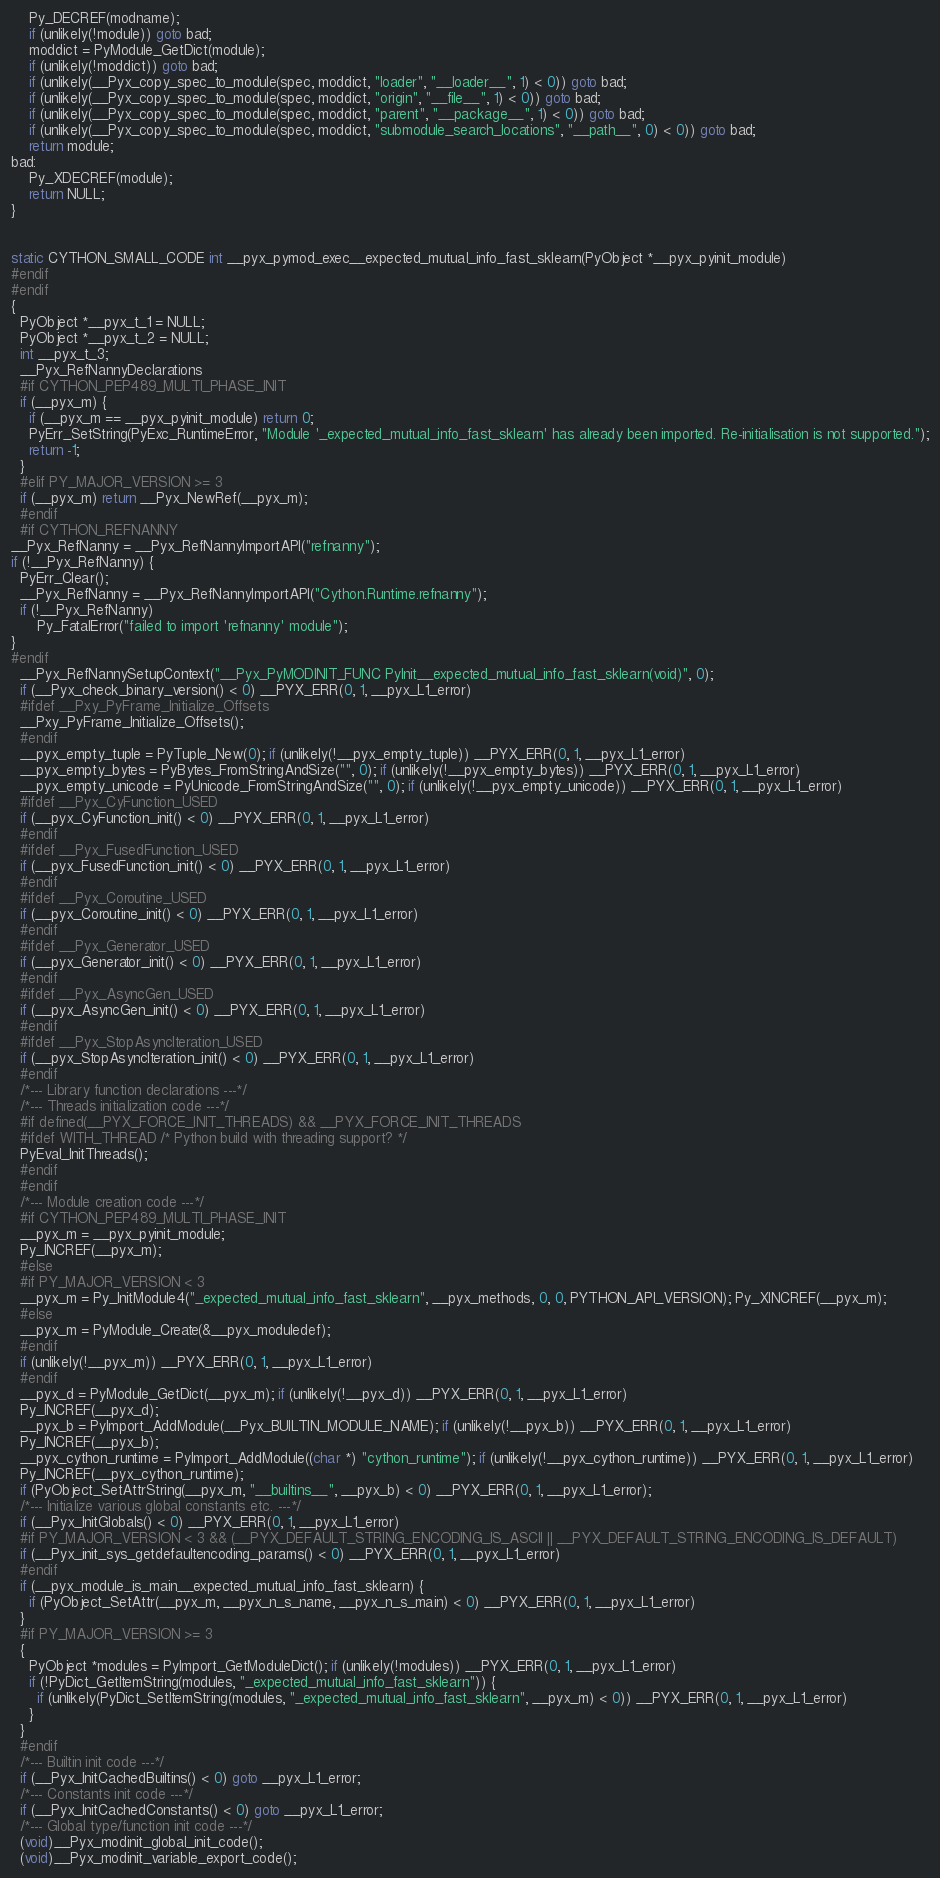Convert code to text. <code><loc_0><loc_0><loc_500><loc_500><_C_>    Py_DECREF(modname);
    if (unlikely(!module)) goto bad;
    moddict = PyModule_GetDict(module);
    if (unlikely(!moddict)) goto bad;
    if (unlikely(__Pyx_copy_spec_to_module(spec, moddict, "loader", "__loader__", 1) < 0)) goto bad;
    if (unlikely(__Pyx_copy_spec_to_module(spec, moddict, "origin", "__file__", 1) < 0)) goto bad;
    if (unlikely(__Pyx_copy_spec_to_module(spec, moddict, "parent", "__package__", 1) < 0)) goto bad;
    if (unlikely(__Pyx_copy_spec_to_module(spec, moddict, "submodule_search_locations", "__path__", 0) < 0)) goto bad;
    return module;
bad:
    Py_XDECREF(module);
    return NULL;
}


static CYTHON_SMALL_CODE int __pyx_pymod_exec__expected_mutual_info_fast_sklearn(PyObject *__pyx_pyinit_module)
#endif
#endif
{
  PyObject *__pyx_t_1 = NULL;
  PyObject *__pyx_t_2 = NULL;
  int __pyx_t_3;
  __Pyx_RefNannyDeclarations
  #if CYTHON_PEP489_MULTI_PHASE_INIT
  if (__pyx_m) {
    if (__pyx_m == __pyx_pyinit_module) return 0;
    PyErr_SetString(PyExc_RuntimeError, "Module '_expected_mutual_info_fast_sklearn' has already been imported. Re-initialisation is not supported.");
    return -1;
  }
  #elif PY_MAJOR_VERSION >= 3
  if (__pyx_m) return __Pyx_NewRef(__pyx_m);
  #endif
  #if CYTHON_REFNANNY
__Pyx_RefNanny = __Pyx_RefNannyImportAPI("refnanny");
if (!__Pyx_RefNanny) {
  PyErr_Clear();
  __Pyx_RefNanny = __Pyx_RefNannyImportAPI("Cython.Runtime.refnanny");
  if (!__Pyx_RefNanny)
      Py_FatalError("failed to import 'refnanny' module");
}
#endif
  __Pyx_RefNannySetupContext("__Pyx_PyMODINIT_FUNC PyInit__expected_mutual_info_fast_sklearn(void)", 0);
  if (__Pyx_check_binary_version() < 0) __PYX_ERR(0, 1, __pyx_L1_error)
  #ifdef __Pxy_PyFrame_Initialize_Offsets
  __Pxy_PyFrame_Initialize_Offsets();
  #endif
  __pyx_empty_tuple = PyTuple_New(0); if (unlikely(!__pyx_empty_tuple)) __PYX_ERR(0, 1, __pyx_L1_error)
  __pyx_empty_bytes = PyBytes_FromStringAndSize("", 0); if (unlikely(!__pyx_empty_bytes)) __PYX_ERR(0, 1, __pyx_L1_error)
  __pyx_empty_unicode = PyUnicode_FromStringAndSize("", 0); if (unlikely(!__pyx_empty_unicode)) __PYX_ERR(0, 1, __pyx_L1_error)
  #ifdef __Pyx_CyFunction_USED
  if (__pyx_CyFunction_init() < 0) __PYX_ERR(0, 1, __pyx_L1_error)
  #endif
  #ifdef __Pyx_FusedFunction_USED
  if (__pyx_FusedFunction_init() < 0) __PYX_ERR(0, 1, __pyx_L1_error)
  #endif
  #ifdef __Pyx_Coroutine_USED
  if (__pyx_Coroutine_init() < 0) __PYX_ERR(0, 1, __pyx_L1_error)
  #endif
  #ifdef __Pyx_Generator_USED
  if (__pyx_Generator_init() < 0) __PYX_ERR(0, 1, __pyx_L1_error)
  #endif
  #ifdef __Pyx_AsyncGen_USED
  if (__pyx_AsyncGen_init() < 0) __PYX_ERR(0, 1, __pyx_L1_error)
  #endif
  #ifdef __Pyx_StopAsyncIteration_USED
  if (__pyx_StopAsyncIteration_init() < 0) __PYX_ERR(0, 1, __pyx_L1_error)
  #endif
  /*--- Library function declarations ---*/
  /*--- Threads initialization code ---*/
  #if defined(__PYX_FORCE_INIT_THREADS) && __PYX_FORCE_INIT_THREADS
  #ifdef WITH_THREAD /* Python build with threading support? */
  PyEval_InitThreads();
  #endif
  #endif
  /*--- Module creation code ---*/
  #if CYTHON_PEP489_MULTI_PHASE_INIT
  __pyx_m = __pyx_pyinit_module;
  Py_INCREF(__pyx_m);
  #else
  #if PY_MAJOR_VERSION < 3
  __pyx_m = Py_InitModule4("_expected_mutual_info_fast_sklearn", __pyx_methods, 0, 0, PYTHON_API_VERSION); Py_XINCREF(__pyx_m);
  #else
  __pyx_m = PyModule_Create(&__pyx_moduledef);
  #endif
  if (unlikely(!__pyx_m)) __PYX_ERR(0, 1, __pyx_L1_error)
  #endif
  __pyx_d = PyModule_GetDict(__pyx_m); if (unlikely(!__pyx_d)) __PYX_ERR(0, 1, __pyx_L1_error)
  Py_INCREF(__pyx_d);
  __pyx_b = PyImport_AddModule(__Pyx_BUILTIN_MODULE_NAME); if (unlikely(!__pyx_b)) __PYX_ERR(0, 1, __pyx_L1_error)
  Py_INCREF(__pyx_b);
  __pyx_cython_runtime = PyImport_AddModule((char *) "cython_runtime"); if (unlikely(!__pyx_cython_runtime)) __PYX_ERR(0, 1, __pyx_L1_error)
  Py_INCREF(__pyx_cython_runtime);
  if (PyObject_SetAttrString(__pyx_m, "__builtins__", __pyx_b) < 0) __PYX_ERR(0, 1, __pyx_L1_error);
  /*--- Initialize various global constants etc. ---*/
  if (__Pyx_InitGlobals() < 0) __PYX_ERR(0, 1, __pyx_L1_error)
  #if PY_MAJOR_VERSION < 3 && (__PYX_DEFAULT_STRING_ENCODING_IS_ASCII || __PYX_DEFAULT_STRING_ENCODING_IS_DEFAULT)
  if (__Pyx_init_sys_getdefaultencoding_params() < 0) __PYX_ERR(0, 1, __pyx_L1_error)
  #endif
  if (__pyx_module_is_main__expected_mutual_info_fast_sklearn) {
    if (PyObject_SetAttr(__pyx_m, __pyx_n_s_name, __pyx_n_s_main) < 0) __PYX_ERR(0, 1, __pyx_L1_error)
  }
  #if PY_MAJOR_VERSION >= 3
  {
    PyObject *modules = PyImport_GetModuleDict(); if (unlikely(!modules)) __PYX_ERR(0, 1, __pyx_L1_error)
    if (!PyDict_GetItemString(modules, "_expected_mutual_info_fast_sklearn")) {
      if (unlikely(PyDict_SetItemString(modules, "_expected_mutual_info_fast_sklearn", __pyx_m) < 0)) __PYX_ERR(0, 1, __pyx_L1_error)
    }
  }
  #endif
  /*--- Builtin init code ---*/
  if (__Pyx_InitCachedBuiltins() < 0) goto __pyx_L1_error;
  /*--- Constants init code ---*/
  if (__Pyx_InitCachedConstants() < 0) goto __pyx_L1_error;
  /*--- Global type/function init code ---*/
  (void)__Pyx_modinit_global_init_code();
  (void)__Pyx_modinit_variable_export_code();</code> 